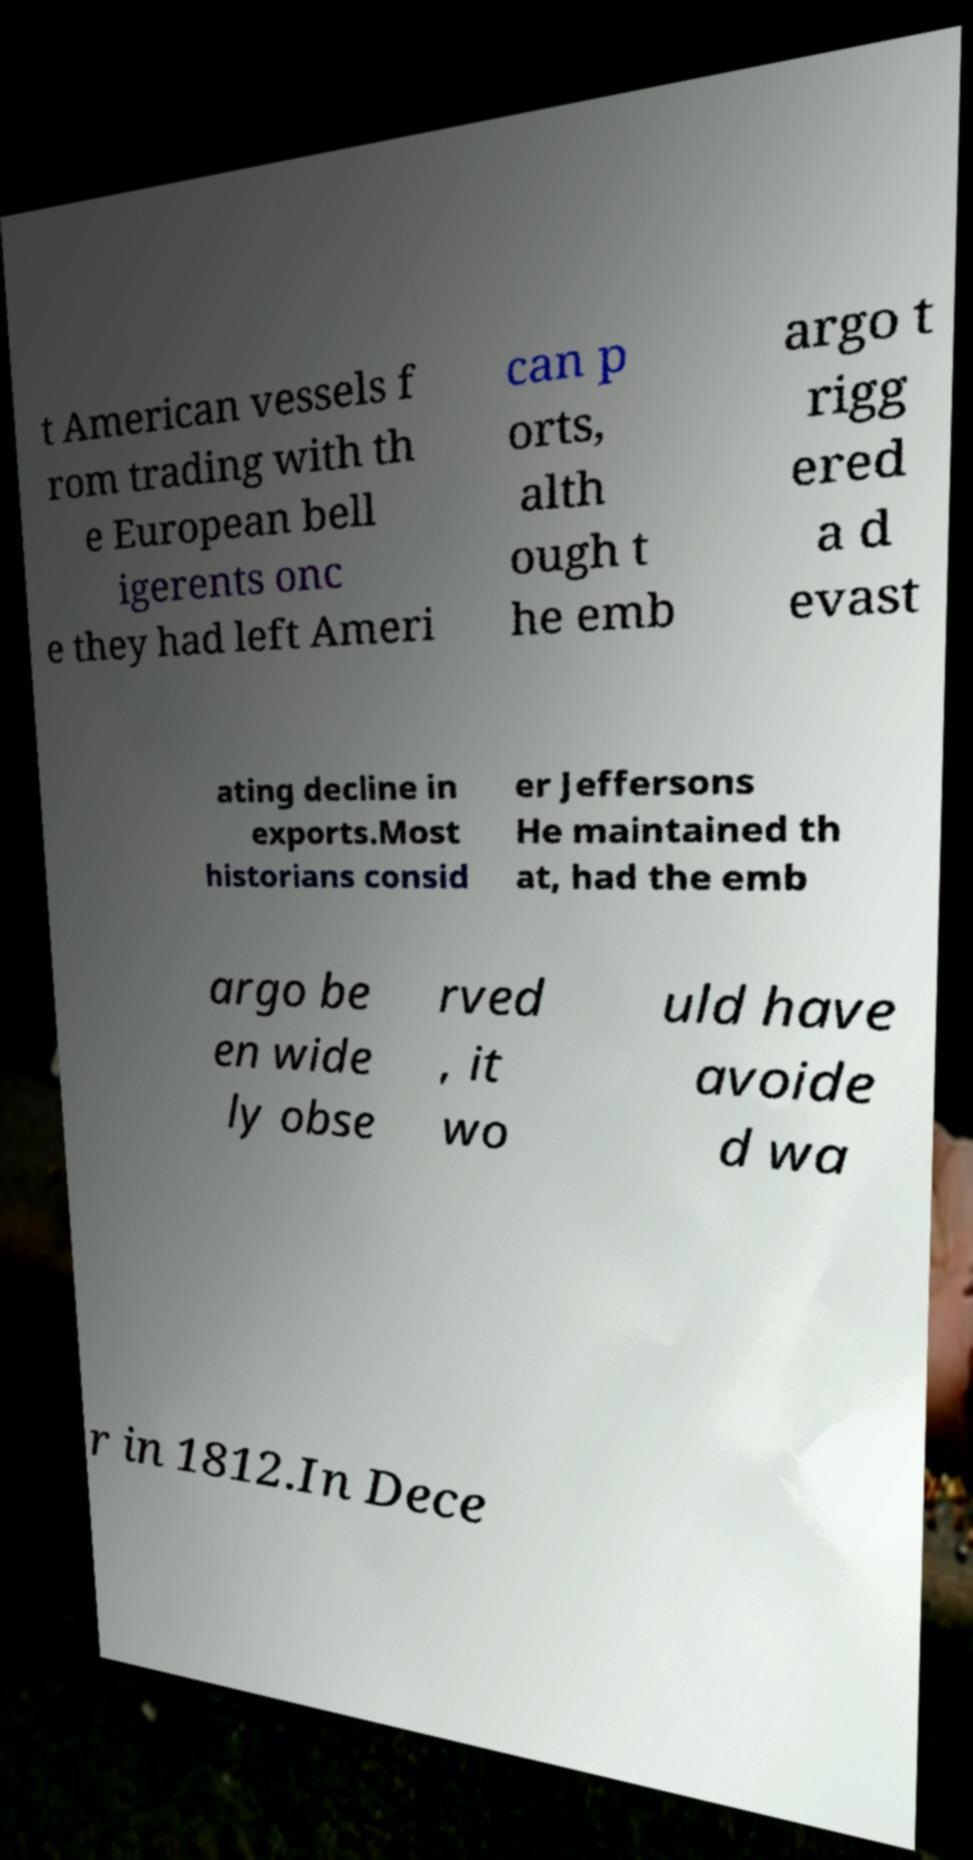I need the written content from this picture converted into text. Can you do that? t American vessels f rom trading with th e European bell igerents onc e they had left Ameri can p orts, alth ough t he emb argo t rigg ered a d evast ating decline in exports.Most historians consid er Jeffersons He maintained th at, had the emb argo be en wide ly obse rved , it wo uld have avoide d wa r in 1812.In Dece 